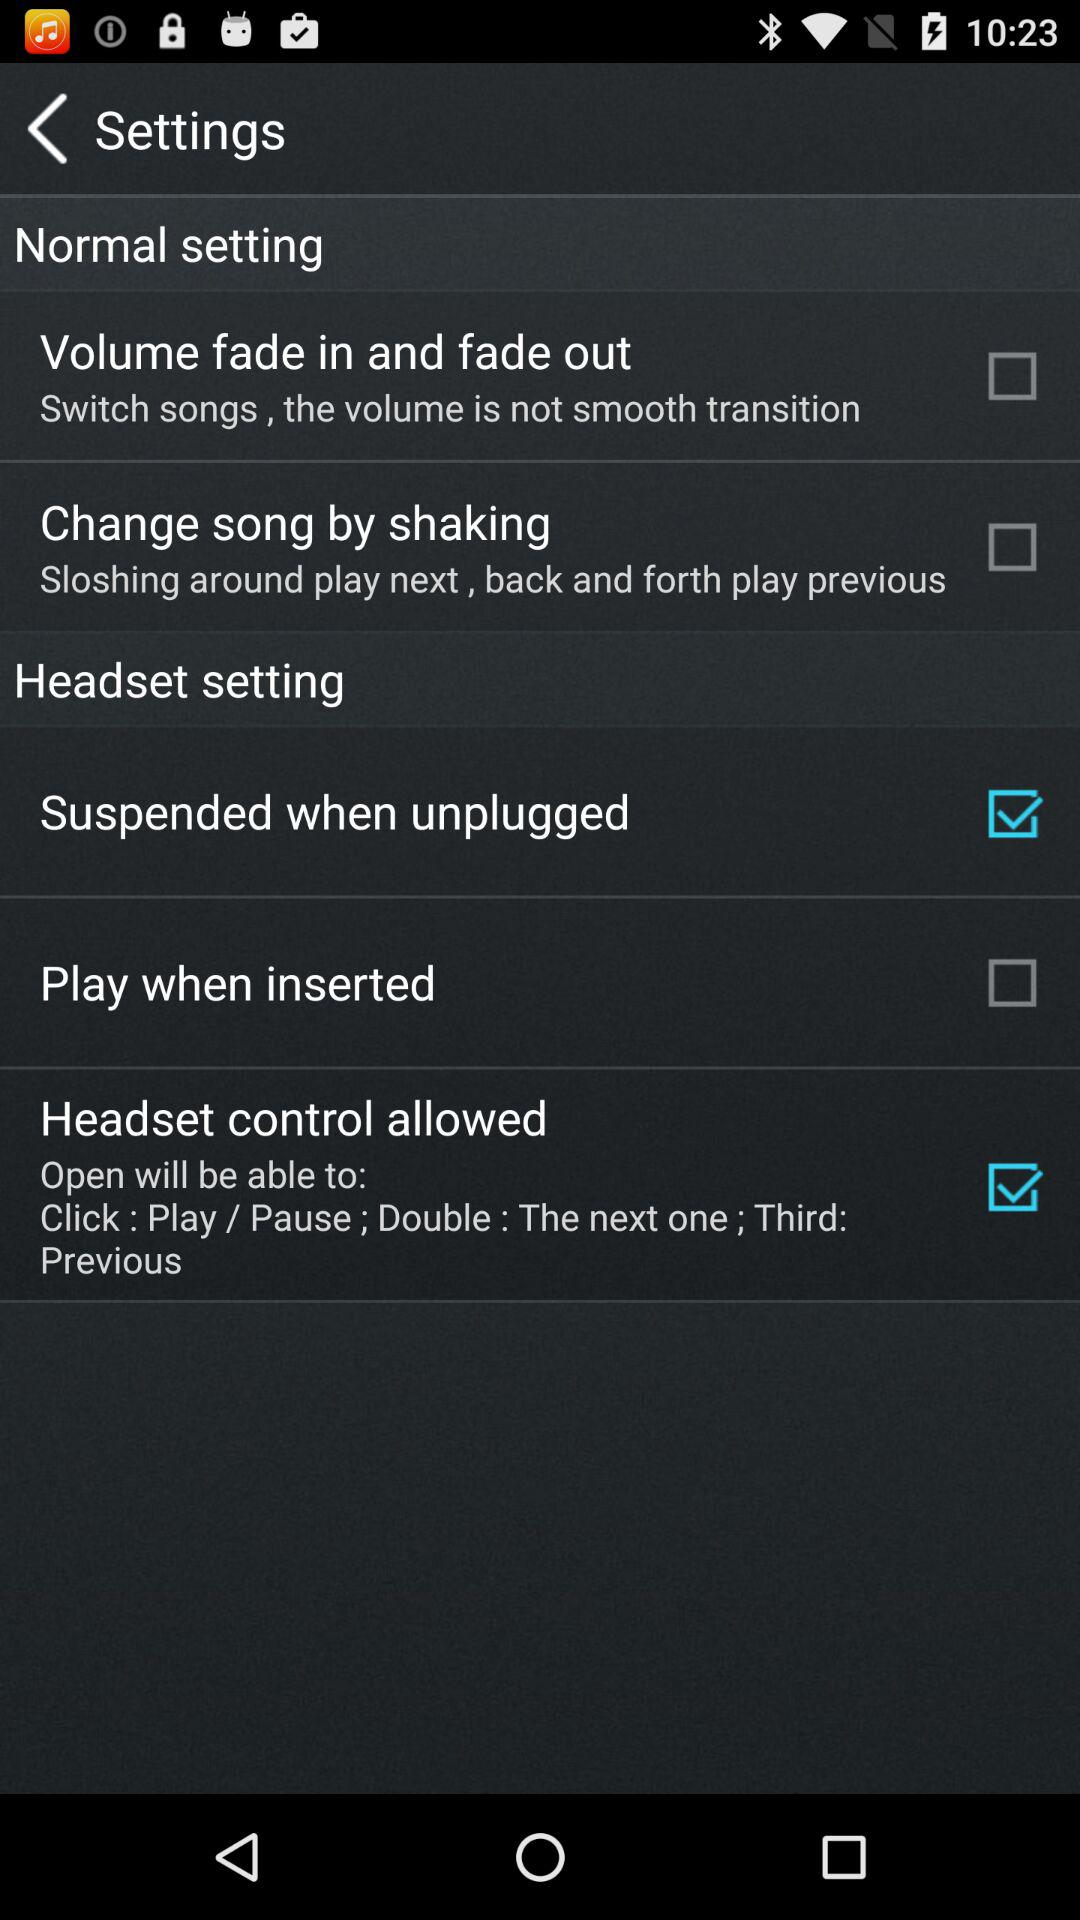What's the status of "Change song by shaking"? The status is off. 